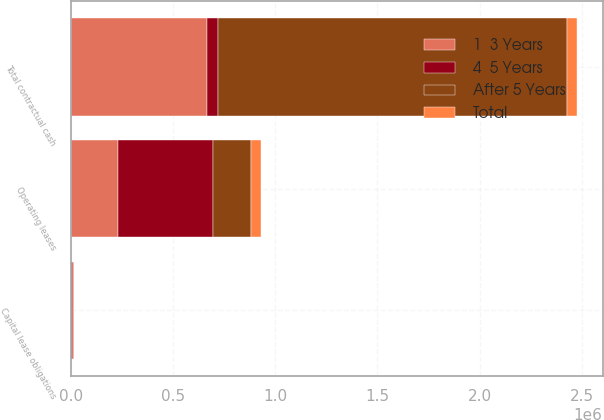Convert chart to OTSL. <chart><loc_0><loc_0><loc_500><loc_500><stacked_bar_chart><ecel><fcel>Capital lease obligations<fcel>Operating leases<fcel>Total contractual cash<nl><fcel>4  5 Years<fcel>10393<fcel>468194<fcel>50154<nl><fcel>After 5 Years<fcel>690<fcel>181800<fcel>1.70803e+06<nl><fcel>1  3 Years<fcel>1476<fcel>230044<fcel>668658<nl><fcel>Total<fcel>1616<fcel>48450<fcel>50154<nl></chart> 